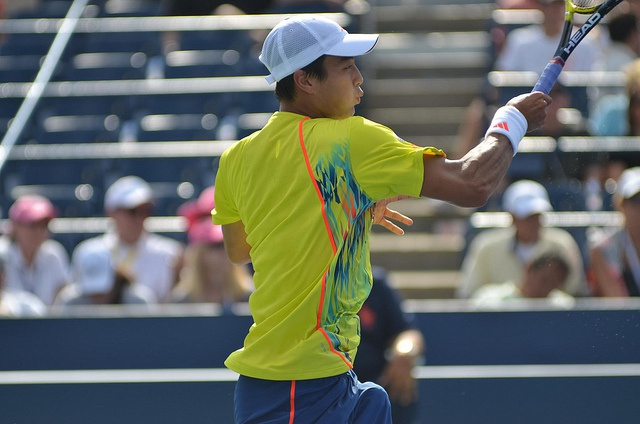Describe the objects in this image and their specific colors. I can see people in brown, olive, navy, and gray tones, people in brown, darkgray, gray, and lightgray tones, people in brown, darkgray, gray, and lavender tones, people in brown, black, gray, navy, and maroon tones, and people in brown, darkgray, gray, and lavender tones in this image. 